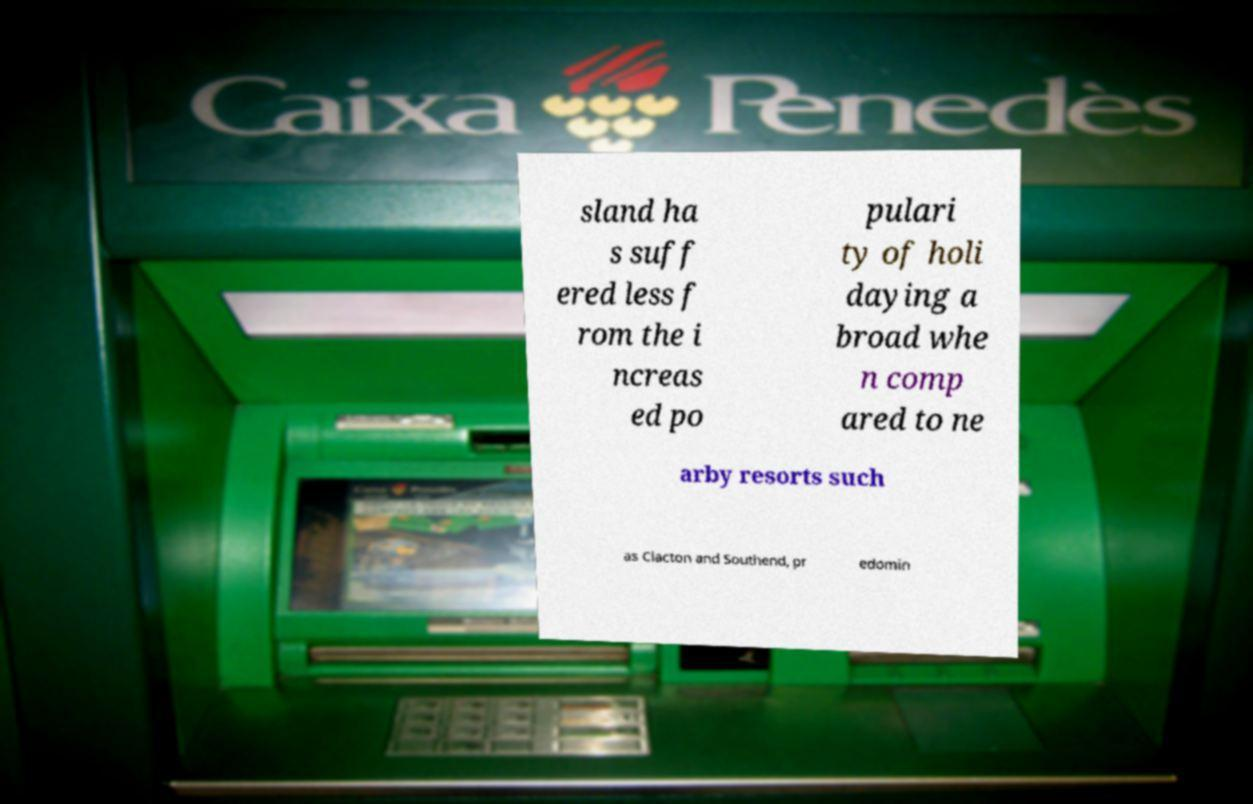I need the written content from this picture converted into text. Can you do that? sland ha s suff ered less f rom the i ncreas ed po pulari ty of holi daying a broad whe n comp ared to ne arby resorts such as Clacton and Southend, pr edomin 